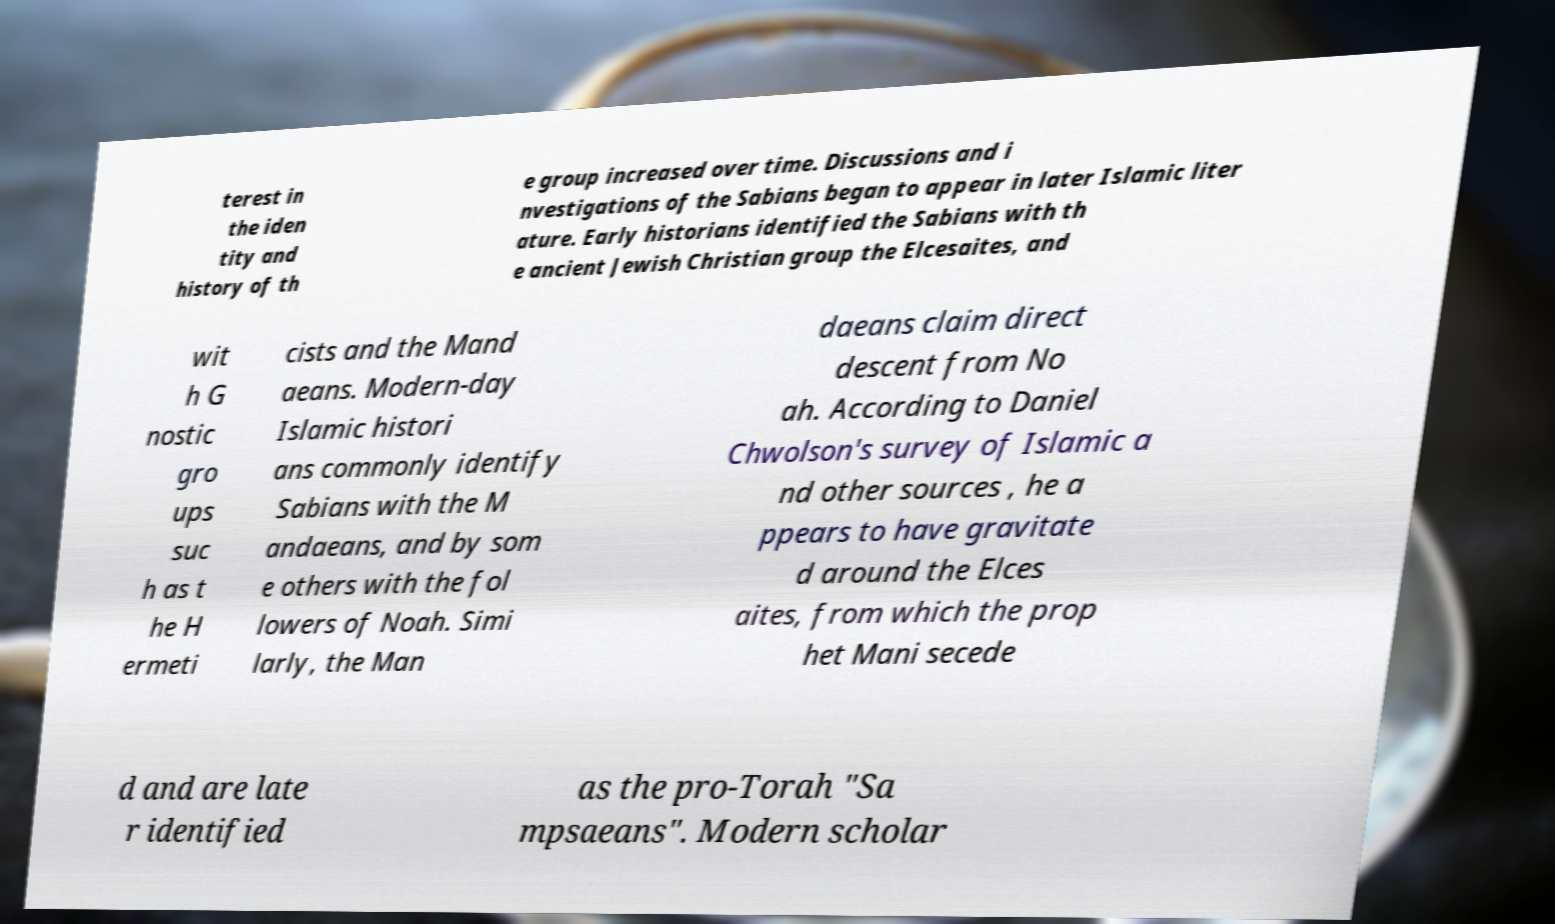I need the written content from this picture converted into text. Can you do that? terest in the iden tity and history of th e group increased over time. Discussions and i nvestigations of the Sabians began to appear in later Islamic liter ature. Early historians identified the Sabians with th e ancient Jewish Christian group the Elcesaites, and wit h G nostic gro ups suc h as t he H ermeti cists and the Mand aeans. Modern-day Islamic histori ans commonly identify Sabians with the M andaeans, and by som e others with the fol lowers of Noah. Simi larly, the Man daeans claim direct descent from No ah. According to Daniel Chwolson's survey of Islamic a nd other sources , he a ppears to have gravitate d around the Elces aites, from which the prop het Mani secede d and are late r identified as the pro-Torah "Sa mpsaeans". Modern scholar 